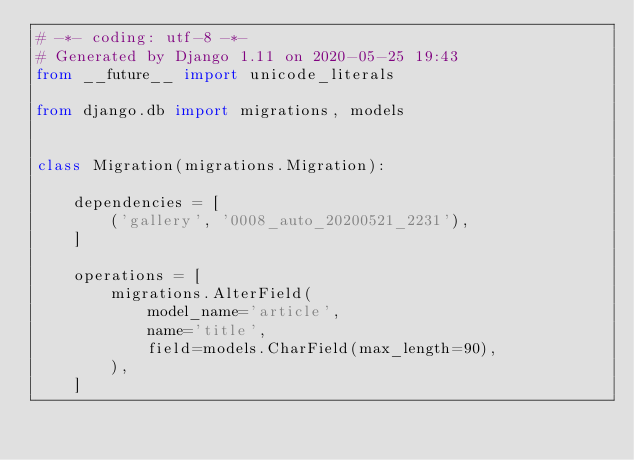Convert code to text. <code><loc_0><loc_0><loc_500><loc_500><_Python_># -*- coding: utf-8 -*-
# Generated by Django 1.11 on 2020-05-25 19:43
from __future__ import unicode_literals

from django.db import migrations, models


class Migration(migrations.Migration):

    dependencies = [
        ('gallery', '0008_auto_20200521_2231'),
    ]

    operations = [
        migrations.AlterField(
            model_name='article',
            name='title',
            field=models.CharField(max_length=90),
        ),
    ]
</code> 